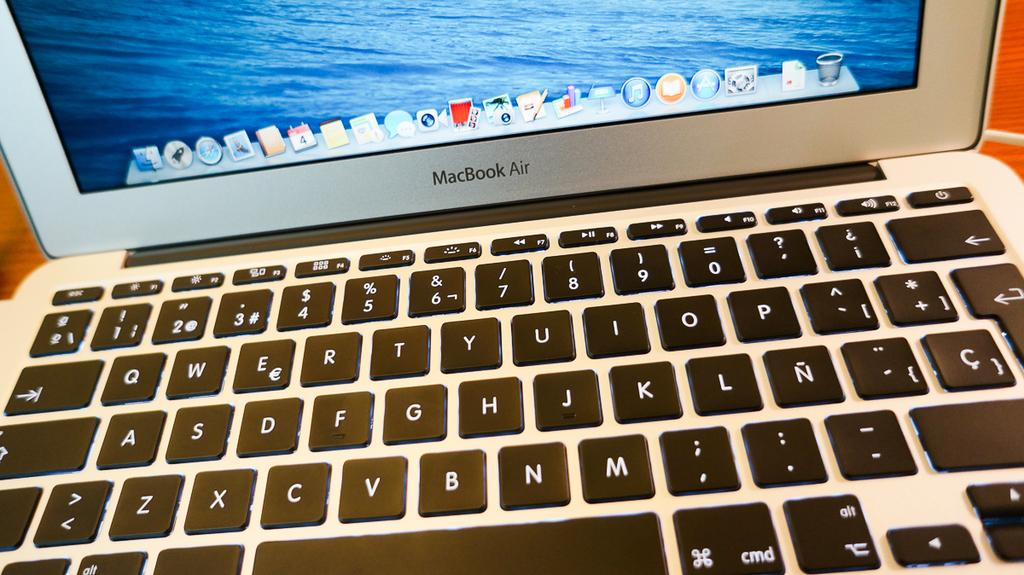<image>
Write a terse but informative summary of the picture. A shot of the desktop of a MacBook Air computer 